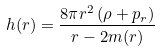<formula> <loc_0><loc_0><loc_500><loc_500>h ( r ) = \frac { 8 \pi r ^ { 2 } \left ( \rho + p _ { r } \right ) } { r - 2 m ( r ) }</formula> 